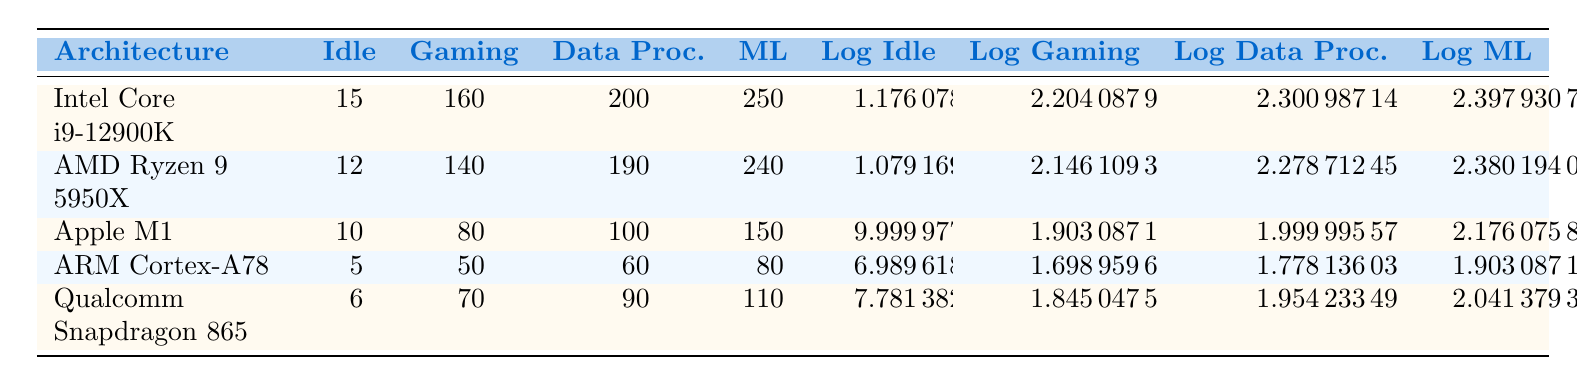What is the power consumption of the Intel Core i9-12900K under gaming workload? The table indicates that the Intel Core i9-12900K consumes 160 watts during gaming workload, directly listed under the Gaming column.
Answer: 160 watts Which CPU architecture has the lowest idle power consumption? By reviewing the Idle column, the ARM Cortex-A78 has an idle power consumption of 5 watts, which is the lowest compared to others.
Answer: ARM Cortex-A78 What is the average power consumption for data processing across all CPU architectures? First, add the power consumption values for Data Processing: 200 + 190 + 100 + 60 + 90 = 640 watts. Then, divide by the number of architectures (5): 640 / 5 = 128 watts.
Answer: 128 watts Is the power consumption of the Qualcomm Snapdragon 865 under the machine learning workload higher than the ARM Cortex-A78? The Qualcomm Snapdragon 865 has a machine learning consumption of 110 watts, while the ARM Cortex-A78 has 80 watts. Since 110 watts is greater than 80 watts, the answer is yes.
Answer: Yes What is the difference in power consumption under gaming workload between the AMD Ryzen 9 5950X and the Apple M1? The gaming consumption for AMD Ryzen 9 5950X is 140 watts and for Apple M1 it is 80 watts. The difference is 140 - 80 = 60 watts.
Answer: 60 watts Which CPU architecture has the highest power consumption during machine learning workloads? By examining the Machine Learning column, the Intel Core i9-12900K has the highest consumption at 250 watts, surpassing all other architectures.
Answer: Intel Core i9-12900K What is the logarithmic value of the gaming workload for the AMD Ryzen 9 5950X? The table shows the power consumption for Gaming for AMD Ryzen 9 5950X is 140 watts. The logarithmic value calculated is log10(140), which equals approximately 2.146.
Answer: 2.146 Does the Apple M1 consume more power during data processing than the Qualcomm Snapdragon 865? Looking at the Data Processing column, the Apple M1 shows 100 watts while the Qualcomm Snapdragon 865 shows 90 watts. Since 100 is greater than 90, the statement is true.
Answer: Yes 